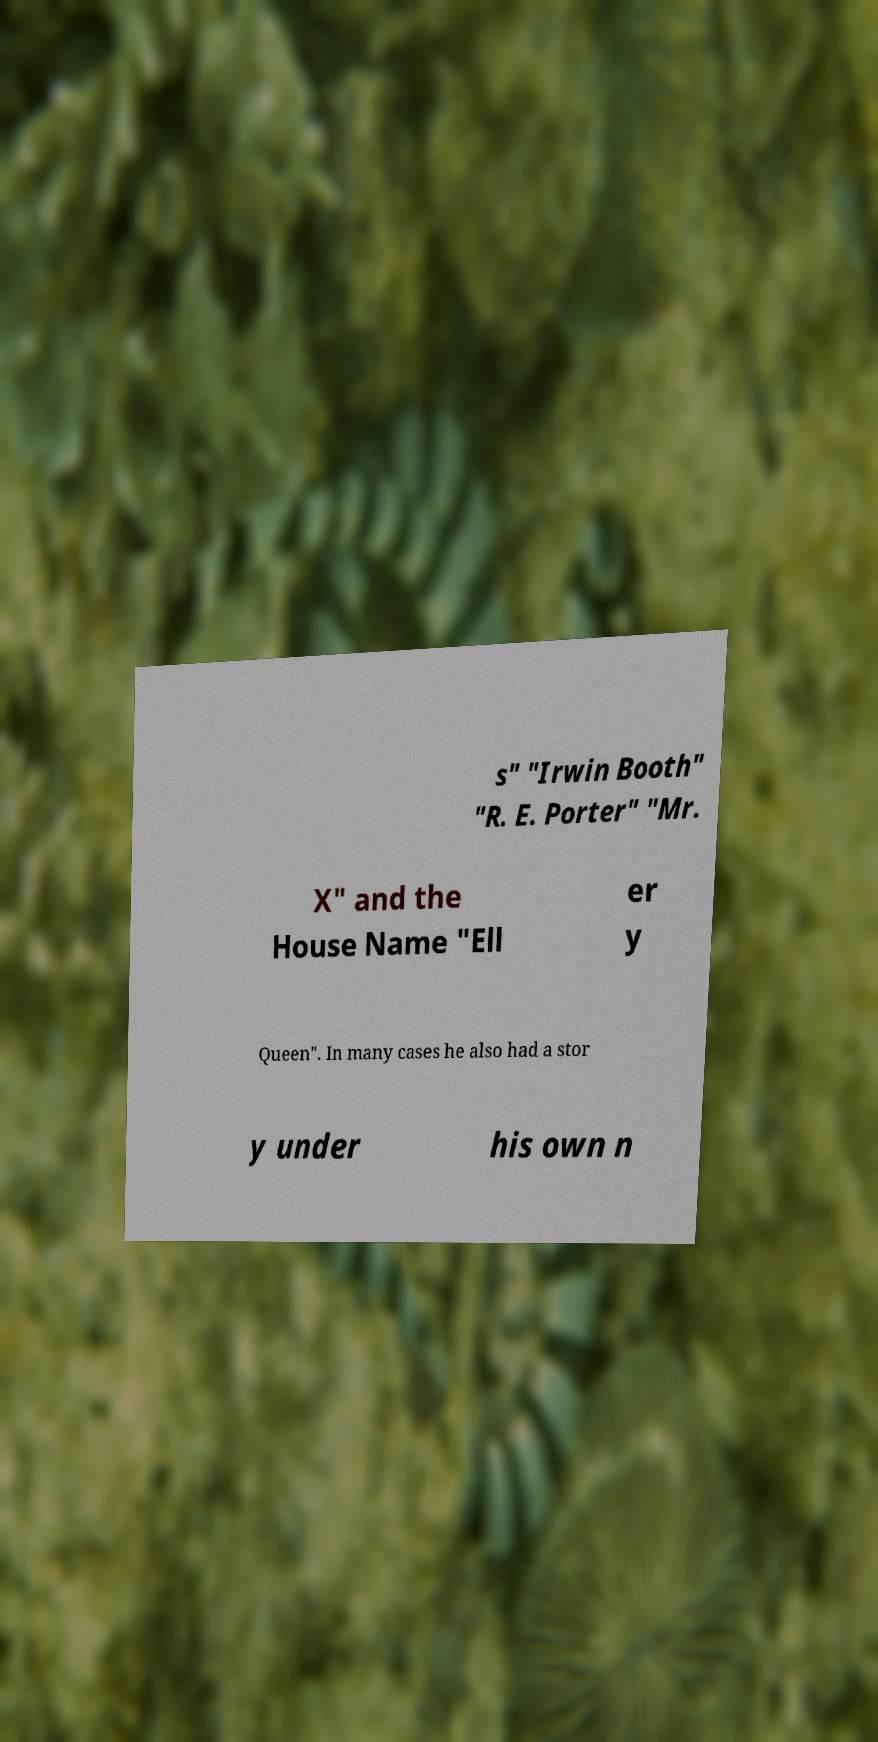I need the written content from this picture converted into text. Can you do that? s" "Irwin Booth" "R. E. Porter" "Mr. X" and the House Name "Ell er y Queen". In many cases he also had a stor y under his own n 